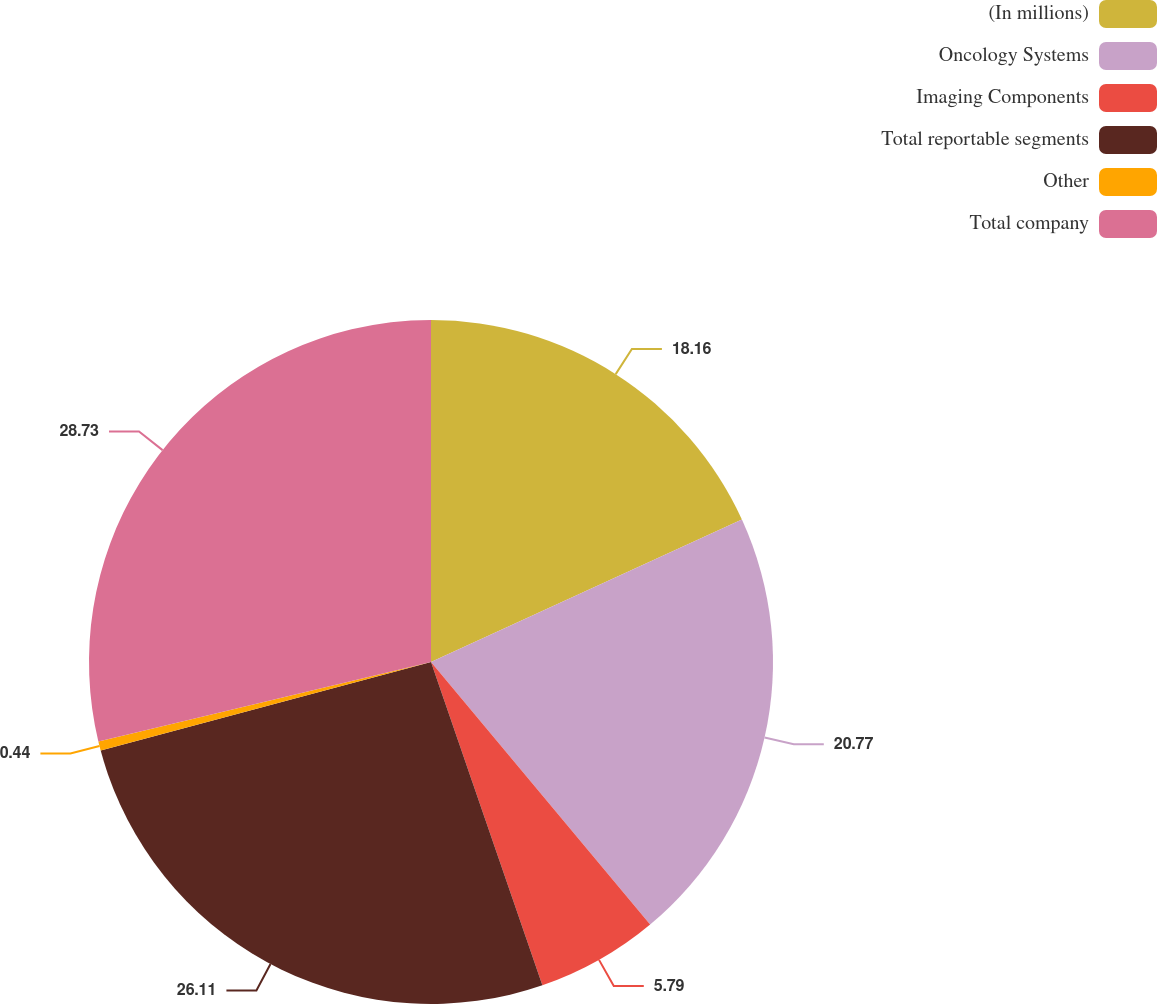Convert chart. <chart><loc_0><loc_0><loc_500><loc_500><pie_chart><fcel>(In millions)<fcel>Oncology Systems<fcel>Imaging Components<fcel>Total reportable segments<fcel>Other<fcel>Total company<nl><fcel>18.16%<fcel>20.77%<fcel>5.79%<fcel>26.11%<fcel>0.44%<fcel>28.73%<nl></chart> 